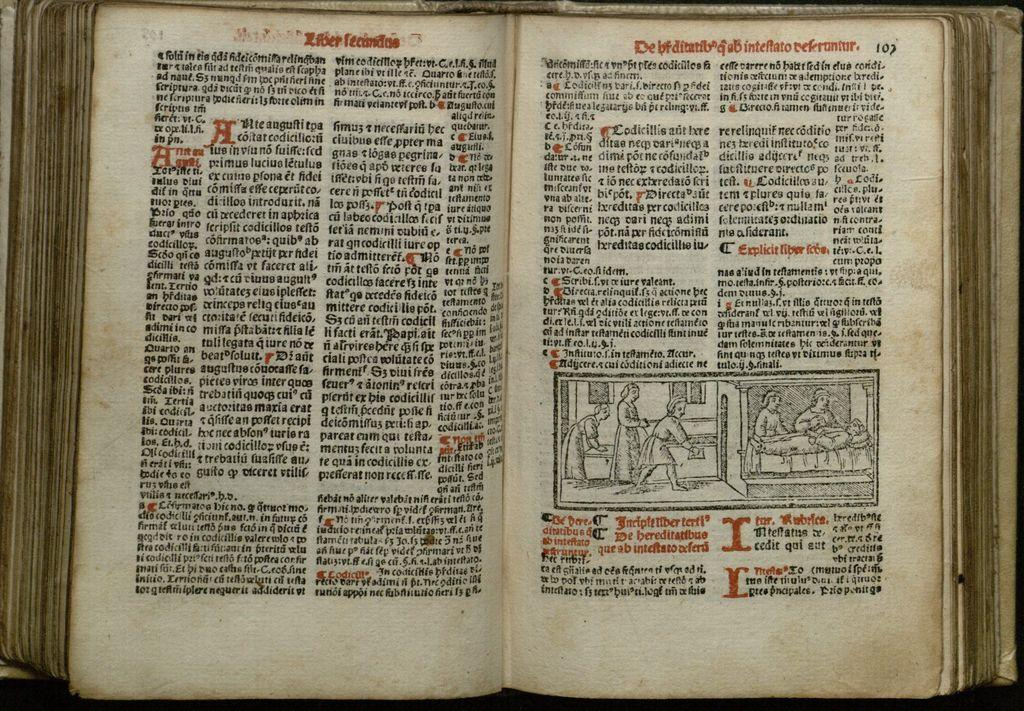<image>
Share a concise interpretation of the image provided. A book opened to page 103 which has a couple of pictures on it of people. 